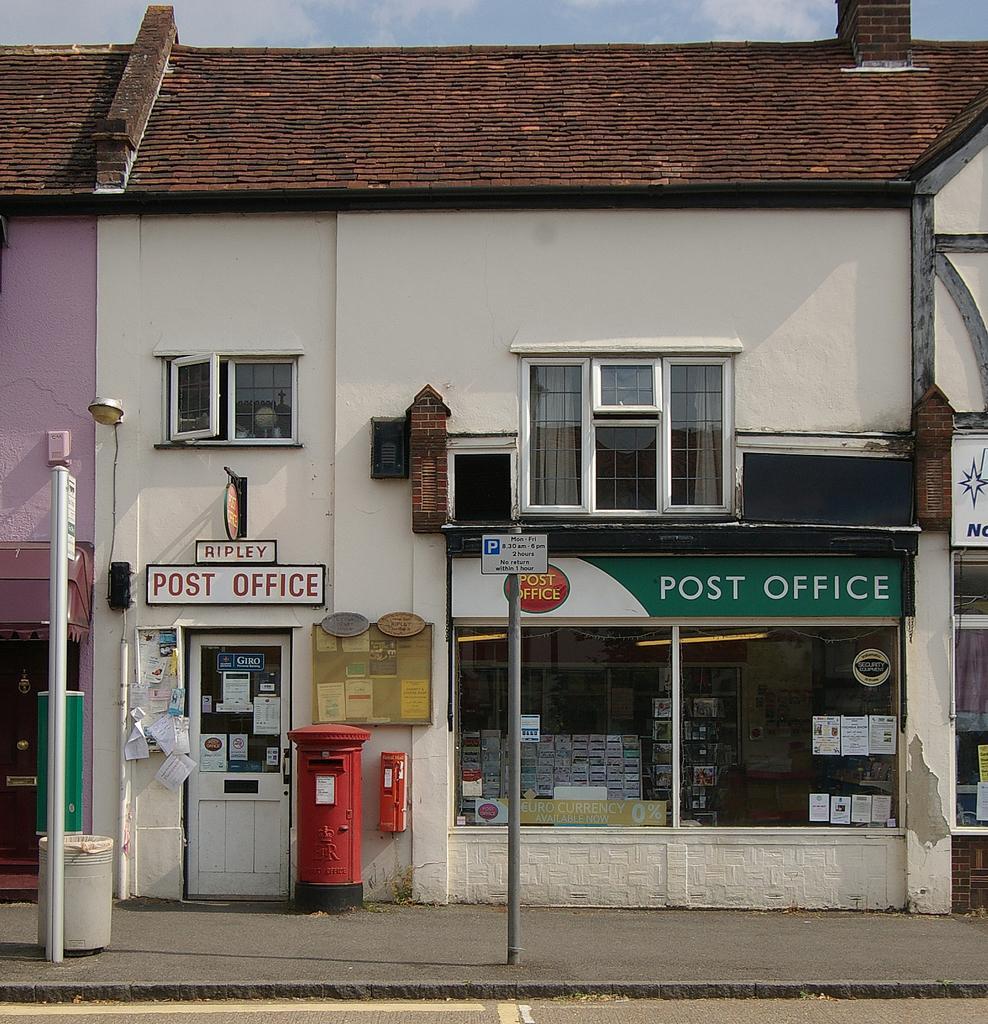Could you give a brief overview of what you see in this image? In this image I can see the road, the sidewalk, few poles, few boards and a building which is white and brown in color. I can see a window and in the background I can see the sky. 